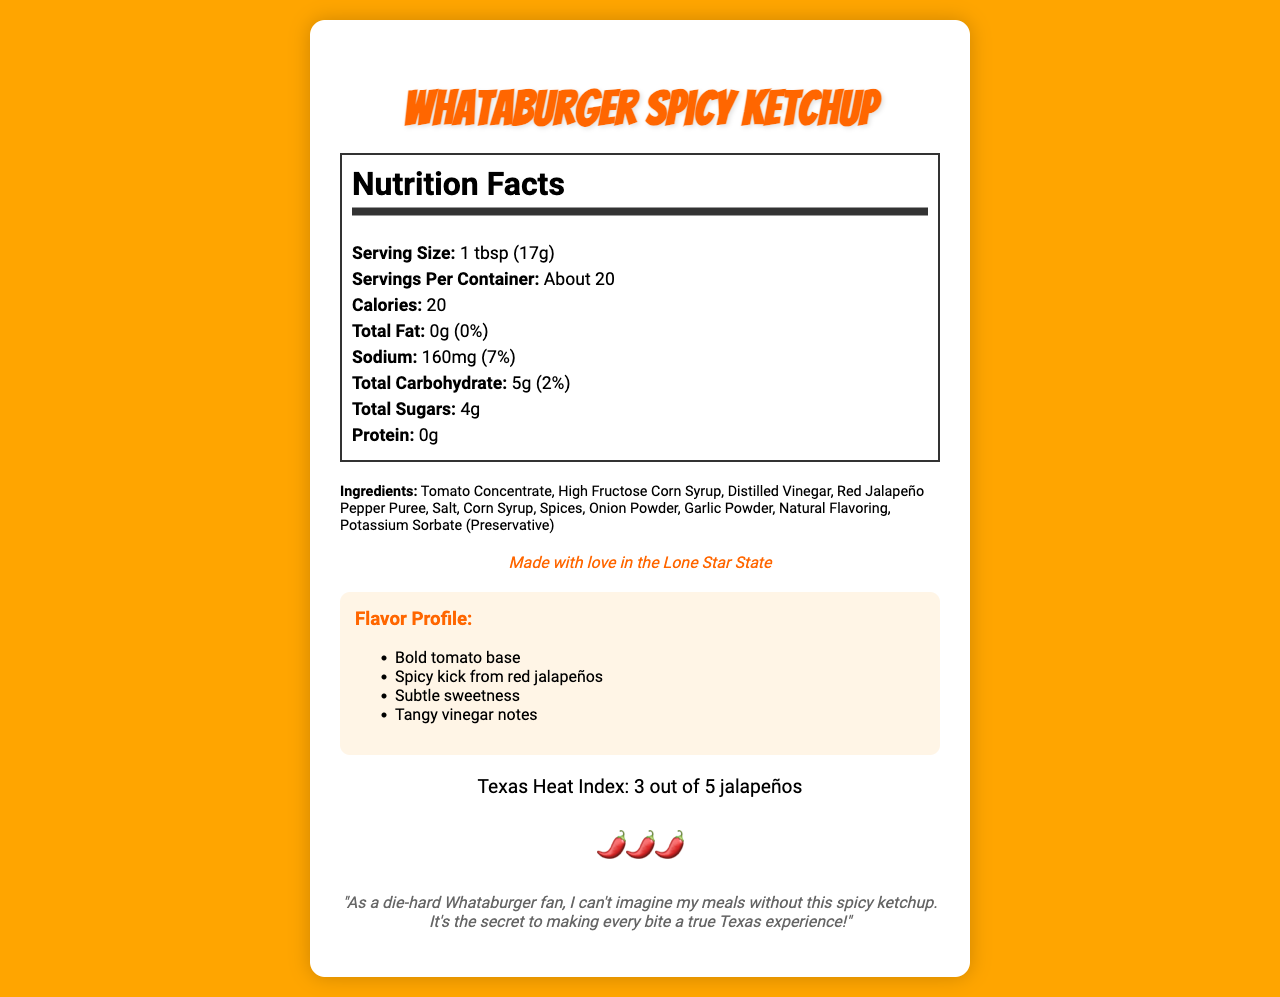what is the serving size of Whataburger Spicy Ketchup? The serving size is directly stated in the nutrition facts section of the document.
Answer: 1 tbsp (17g) how many calories are in one serving of Whataburger Spicy Ketchup? The number of calories per serving is listed as "Calories: 20" in the nutrition facts section.
Answer: 20 what ingredients give Whataburger Spicy Ketchup its unique flavor? The ingredients list includes Red jalapeño pepper puree, spices, and natural flavoring, which contribute to the unique flavor profile.
Answer: Red jalapeño pepper puree, spices, natural flavoring what is the Texas heat index rating for this ketchup? The Texas Heat Index for Whataburger Spicy Ketchup is stated as "3 out of 5 jalapeños" in the document.
Answer: 3 out of 5 jalapeños how should this ketchup be stored after opening? The storage instructions specify refrigeration after opening to maintain maximum flavor.
Answer: Refrigerate after opening for maximum flavor which of the following is NOT an ingredient in Whataburger Spicy Ketchup? A. High Fructose Corn Syrup B. Tomatoes C. Mustard D. Garlic Powder Mustard is not listed among the ingredients in the document.
Answer: C. Mustard what percentage of the daily recommended sodium intake does one serving provide? A. 3% B. 5% C. 7% The nutrition facts label states that one serving provides 160mg of sodium, which is 7% of the daily recommended intake.
Answer: C. 7% what are the total sugars in one serving? A. 2g B. 4g C. 1g D. 0g The nutrition facts state that each serving contains 4g of total sugars.
Answer: B. 4g does Whataburger Spicy Ketchup contain any major allergens? The allergen information section specifies that it contains no major allergens.
Answer: No is there any fat in Whataburger Spicy Ketchup? The nutrition facts label shows 0g of total fat and 0% daily value.
Answer: No can the shelf life of the product be determined from the document? The shelf life is described as best if used within 6 months of opening.
Answer: Yes describe the main flavor profile of Whataburger Spicy Ketchup in this document The flavor profile section describes a bold tomato base, a spicy kick from red jalapeños, subtle sweetness, and tangy vinegar notes.
Answer: Bold tomato base, spicy kick from red jalapeños, subtle sweetness, tangy vinegar notes can the document provide the price of Whataburger Spicy Ketchup? The document does not include any pricing information.
Answer: Not enough information 